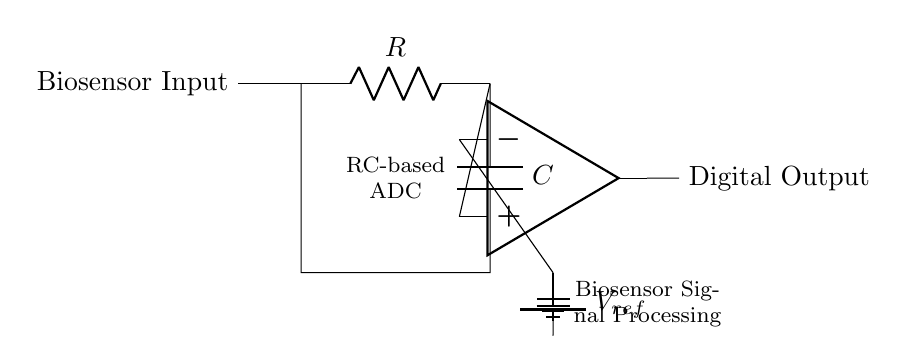What are the main components in the circuit? The circuit is made up of a resistor (R), a capacitor (C), an operational amplifier (op amp), and a reference voltage source (V_ref). Each of these components plays a crucial role in the function of the RC-based analog-to-digital converter.
Answer: resistor, capacitor, op amp, reference voltage What type of circuit is this? This is an RC-based analog-to-digital converter. The use of resistor-capacitor integration allows for the conversion of analog signals from the biosensor to digital form.
Answer: RC-based analog-to-digital converter What is the purpose of the capacitor in this circuit? The capacitor temporarily stores charge, helping to smooth out the signal from the biosensor before it is processed by the op amp. This allows for more accurate digital representation of the analog signal.
Answer: smooths signal What is the reference voltage used for? The reference voltage (V_ref) sets a level against which the input signal is compared by the operational amplifier, allowing the op amp to determine when to switch the output from low to high based on the input voltage.
Answer: comparison level How does the operational amplifier function in this circuit? The operational amplifier acts as a comparator, assessing the voltage level of the signal from the capacitor against the reference voltage to produce a digital output based on that comparison.
Answer: comparator What type of signals does this circuit process? This circuit processes analog signals generated by the biosensor and converts them into a digital format for further analysis or display.
Answer: biosensor signals What is the significance of the resistor in the RC circuit? The resistor controls the charging and discharging rate of the capacitor, which affects the time constant of the RC circuit and ultimately influences how fast the circuit can respond to changes in the input signal.
Answer: controls rate 